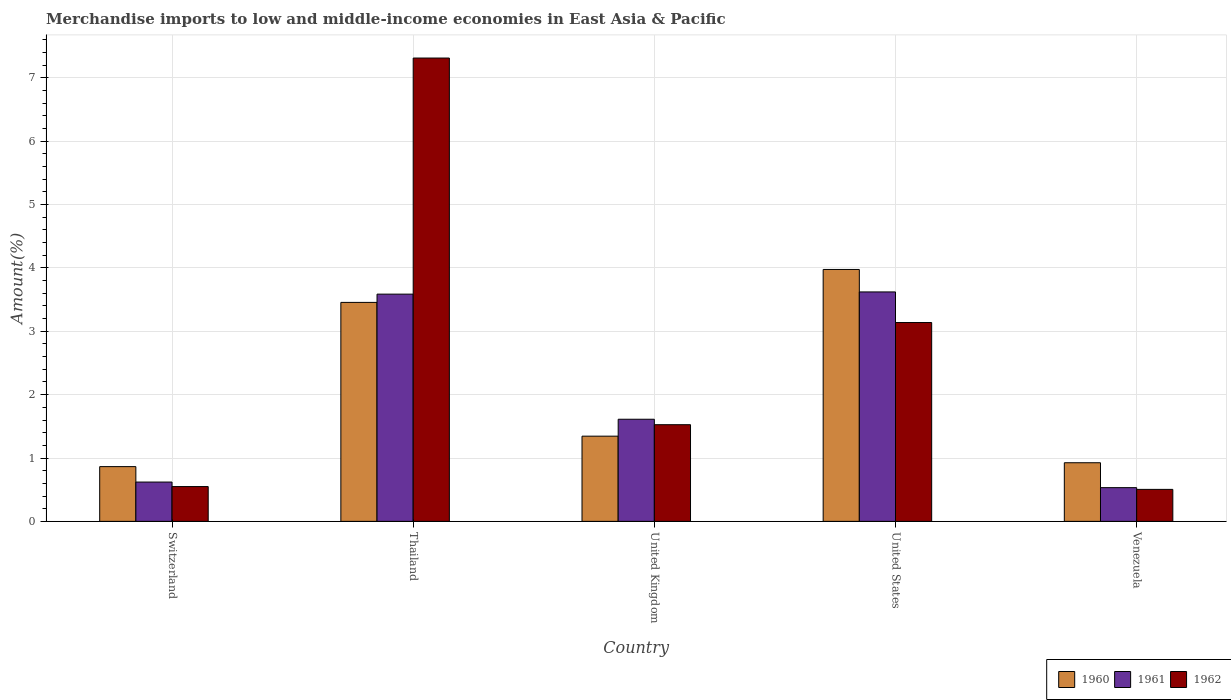How many groups of bars are there?
Make the answer very short. 5. Are the number of bars per tick equal to the number of legend labels?
Offer a very short reply. Yes. Are the number of bars on each tick of the X-axis equal?
Your answer should be very brief. Yes. How many bars are there on the 3rd tick from the right?
Provide a succinct answer. 3. What is the label of the 1st group of bars from the left?
Ensure brevity in your answer.  Switzerland. What is the percentage of amount earned from merchandise imports in 1962 in Thailand?
Provide a short and direct response. 7.31. Across all countries, what is the maximum percentage of amount earned from merchandise imports in 1961?
Give a very brief answer. 3.62. Across all countries, what is the minimum percentage of amount earned from merchandise imports in 1961?
Offer a terse response. 0.53. In which country was the percentage of amount earned from merchandise imports in 1960 minimum?
Provide a short and direct response. Switzerland. What is the total percentage of amount earned from merchandise imports in 1962 in the graph?
Keep it short and to the point. 13.03. What is the difference between the percentage of amount earned from merchandise imports in 1962 in United Kingdom and that in Venezuela?
Give a very brief answer. 1.02. What is the difference between the percentage of amount earned from merchandise imports in 1961 in United Kingdom and the percentage of amount earned from merchandise imports in 1962 in Venezuela?
Provide a succinct answer. 1.11. What is the average percentage of amount earned from merchandise imports in 1960 per country?
Give a very brief answer. 2.11. What is the difference between the percentage of amount earned from merchandise imports of/in 1962 and percentage of amount earned from merchandise imports of/in 1960 in Venezuela?
Ensure brevity in your answer.  -0.42. What is the ratio of the percentage of amount earned from merchandise imports in 1962 in United Kingdom to that in United States?
Ensure brevity in your answer.  0.49. Is the percentage of amount earned from merchandise imports in 1961 in Switzerland less than that in United Kingdom?
Keep it short and to the point. Yes. What is the difference between the highest and the second highest percentage of amount earned from merchandise imports in 1961?
Provide a succinct answer. 1.97. What is the difference between the highest and the lowest percentage of amount earned from merchandise imports in 1960?
Make the answer very short. 3.11. In how many countries, is the percentage of amount earned from merchandise imports in 1962 greater than the average percentage of amount earned from merchandise imports in 1962 taken over all countries?
Offer a very short reply. 2. Is it the case that in every country, the sum of the percentage of amount earned from merchandise imports in 1960 and percentage of amount earned from merchandise imports in 1961 is greater than the percentage of amount earned from merchandise imports in 1962?
Offer a terse response. No. How many bars are there?
Your answer should be compact. 15. How many countries are there in the graph?
Offer a very short reply. 5. Are the values on the major ticks of Y-axis written in scientific E-notation?
Offer a very short reply. No. Does the graph contain any zero values?
Offer a very short reply. No. How many legend labels are there?
Keep it short and to the point. 3. How are the legend labels stacked?
Offer a very short reply. Horizontal. What is the title of the graph?
Make the answer very short. Merchandise imports to low and middle-income economies in East Asia & Pacific. What is the label or title of the X-axis?
Your answer should be compact. Country. What is the label or title of the Y-axis?
Provide a short and direct response. Amount(%). What is the Amount(%) of 1960 in Switzerland?
Provide a short and direct response. 0.86. What is the Amount(%) of 1961 in Switzerland?
Give a very brief answer. 0.62. What is the Amount(%) in 1962 in Switzerland?
Make the answer very short. 0.55. What is the Amount(%) in 1960 in Thailand?
Keep it short and to the point. 3.46. What is the Amount(%) in 1961 in Thailand?
Your response must be concise. 3.59. What is the Amount(%) of 1962 in Thailand?
Offer a terse response. 7.31. What is the Amount(%) of 1960 in United Kingdom?
Keep it short and to the point. 1.34. What is the Amount(%) of 1961 in United Kingdom?
Provide a succinct answer. 1.61. What is the Amount(%) in 1962 in United Kingdom?
Keep it short and to the point. 1.53. What is the Amount(%) in 1960 in United States?
Keep it short and to the point. 3.98. What is the Amount(%) of 1961 in United States?
Your answer should be compact. 3.62. What is the Amount(%) of 1962 in United States?
Provide a succinct answer. 3.14. What is the Amount(%) in 1960 in Venezuela?
Your response must be concise. 0.93. What is the Amount(%) of 1961 in Venezuela?
Make the answer very short. 0.53. What is the Amount(%) of 1962 in Venezuela?
Your answer should be very brief. 0.5. Across all countries, what is the maximum Amount(%) of 1960?
Provide a succinct answer. 3.98. Across all countries, what is the maximum Amount(%) in 1961?
Offer a very short reply. 3.62. Across all countries, what is the maximum Amount(%) in 1962?
Offer a terse response. 7.31. Across all countries, what is the minimum Amount(%) in 1960?
Provide a succinct answer. 0.86. Across all countries, what is the minimum Amount(%) of 1961?
Make the answer very short. 0.53. Across all countries, what is the minimum Amount(%) in 1962?
Give a very brief answer. 0.5. What is the total Amount(%) of 1960 in the graph?
Provide a short and direct response. 10.57. What is the total Amount(%) of 1961 in the graph?
Give a very brief answer. 9.97. What is the total Amount(%) of 1962 in the graph?
Provide a succinct answer. 13.03. What is the difference between the Amount(%) of 1960 in Switzerland and that in Thailand?
Ensure brevity in your answer.  -2.59. What is the difference between the Amount(%) of 1961 in Switzerland and that in Thailand?
Your response must be concise. -2.97. What is the difference between the Amount(%) of 1962 in Switzerland and that in Thailand?
Your answer should be very brief. -6.76. What is the difference between the Amount(%) in 1960 in Switzerland and that in United Kingdom?
Provide a succinct answer. -0.48. What is the difference between the Amount(%) of 1961 in Switzerland and that in United Kingdom?
Give a very brief answer. -0.99. What is the difference between the Amount(%) of 1962 in Switzerland and that in United Kingdom?
Your answer should be very brief. -0.98. What is the difference between the Amount(%) in 1960 in Switzerland and that in United States?
Provide a succinct answer. -3.11. What is the difference between the Amount(%) in 1961 in Switzerland and that in United States?
Make the answer very short. -3. What is the difference between the Amount(%) of 1962 in Switzerland and that in United States?
Ensure brevity in your answer.  -2.59. What is the difference between the Amount(%) of 1960 in Switzerland and that in Venezuela?
Ensure brevity in your answer.  -0.06. What is the difference between the Amount(%) in 1961 in Switzerland and that in Venezuela?
Provide a succinct answer. 0.09. What is the difference between the Amount(%) of 1962 in Switzerland and that in Venezuela?
Your answer should be compact. 0.04. What is the difference between the Amount(%) in 1960 in Thailand and that in United Kingdom?
Offer a very short reply. 2.11. What is the difference between the Amount(%) in 1961 in Thailand and that in United Kingdom?
Offer a terse response. 1.97. What is the difference between the Amount(%) in 1962 in Thailand and that in United Kingdom?
Your response must be concise. 5.79. What is the difference between the Amount(%) of 1960 in Thailand and that in United States?
Your answer should be very brief. -0.52. What is the difference between the Amount(%) of 1961 in Thailand and that in United States?
Offer a very short reply. -0.04. What is the difference between the Amount(%) in 1962 in Thailand and that in United States?
Keep it short and to the point. 4.17. What is the difference between the Amount(%) of 1960 in Thailand and that in Venezuela?
Provide a succinct answer. 2.53. What is the difference between the Amount(%) in 1961 in Thailand and that in Venezuela?
Provide a short and direct response. 3.05. What is the difference between the Amount(%) of 1962 in Thailand and that in Venezuela?
Provide a succinct answer. 6.81. What is the difference between the Amount(%) of 1960 in United Kingdom and that in United States?
Your response must be concise. -2.63. What is the difference between the Amount(%) of 1961 in United Kingdom and that in United States?
Offer a terse response. -2.01. What is the difference between the Amount(%) in 1962 in United Kingdom and that in United States?
Offer a very short reply. -1.61. What is the difference between the Amount(%) in 1960 in United Kingdom and that in Venezuela?
Offer a terse response. 0.42. What is the difference between the Amount(%) in 1961 in United Kingdom and that in Venezuela?
Provide a short and direct response. 1.08. What is the difference between the Amount(%) in 1962 in United Kingdom and that in Venezuela?
Make the answer very short. 1.02. What is the difference between the Amount(%) in 1960 in United States and that in Venezuela?
Your response must be concise. 3.05. What is the difference between the Amount(%) in 1961 in United States and that in Venezuela?
Ensure brevity in your answer.  3.09. What is the difference between the Amount(%) of 1962 in United States and that in Venezuela?
Ensure brevity in your answer.  2.63. What is the difference between the Amount(%) of 1960 in Switzerland and the Amount(%) of 1961 in Thailand?
Your answer should be compact. -2.72. What is the difference between the Amount(%) in 1960 in Switzerland and the Amount(%) in 1962 in Thailand?
Provide a short and direct response. -6.45. What is the difference between the Amount(%) in 1961 in Switzerland and the Amount(%) in 1962 in Thailand?
Offer a very short reply. -6.69. What is the difference between the Amount(%) of 1960 in Switzerland and the Amount(%) of 1961 in United Kingdom?
Give a very brief answer. -0.75. What is the difference between the Amount(%) in 1960 in Switzerland and the Amount(%) in 1962 in United Kingdom?
Keep it short and to the point. -0.66. What is the difference between the Amount(%) of 1961 in Switzerland and the Amount(%) of 1962 in United Kingdom?
Your answer should be very brief. -0.91. What is the difference between the Amount(%) of 1960 in Switzerland and the Amount(%) of 1961 in United States?
Offer a very short reply. -2.76. What is the difference between the Amount(%) in 1960 in Switzerland and the Amount(%) in 1962 in United States?
Your answer should be compact. -2.27. What is the difference between the Amount(%) of 1961 in Switzerland and the Amount(%) of 1962 in United States?
Keep it short and to the point. -2.52. What is the difference between the Amount(%) in 1960 in Switzerland and the Amount(%) in 1961 in Venezuela?
Your response must be concise. 0.33. What is the difference between the Amount(%) in 1960 in Switzerland and the Amount(%) in 1962 in Venezuela?
Ensure brevity in your answer.  0.36. What is the difference between the Amount(%) in 1961 in Switzerland and the Amount(%) in 1962 in Venezuela?
Make the answer very short. 0.12. What is the difference between the Amount(%) of 1960 in Thailand and the Amount(%) of 1961 in United Kingdom?
Ensure brevity in your answer.  1.84. What is the difference between the Amount(%) of 1960 in Thailand and the Amount(%) of 1962 in United Kingdom?
Provide a short and direct response. 1.93. What is the difference between the Amount(%) in 1961 in Thailand and the Amount(%) in 1962 in United Kingdom?
Provide a short and direct response. 2.06. What is the difference between the Amount(%) in 1960 in Thailand and the Amount(%) in 1961 in United States?
Ensure brevity in your answer.  -0.17. What is the difference between the Amount(%) in 1960 in Thailand and the Amount(%) in 1962 in United States?
Offer a terse response. 0.32. What is the difference between the Amount(%) of 1961 in Thailand and the Amount(%) of 1962 in United States?
Offer a terse response. 0.45. What is the difference between the Amount(%) in 1960 in Thailand and the Amount(%) in 1961 in Venezuela?
Your response must be concise. 2.92. What is the difference between the Amount(%) of 1960 in Thailand and the Amount(%) of 1962 in Venezuela?
Give a very brief answer. 2.95. What is the difference between the Amount(%) in 1961 in Thailand and the Amount(%) in 1962 in Venezuela?
Your answer should be compact. 3.08. What is the difference between the Amount(%) in 1960 in United Kingdom and the Amount(%) in 1961 in United States?
Your answer should be very brief. -2.28. What is the difference between the Amount(%) of 1960 in United Kingdom and the Amount(%) of 1962 in United States?
Provide a short and direct response. -1.79. What is the difference between the Amount(%) in 1961 in United Kingdom and the Amount(%) in 1962 in United States?
Give a very brief answer. -1.53. What is the difference between the Amount(%) of 1960 in United Kingdom and the Amount(%) of 1961 in Venezuela?
Keep it short and to the point. 0.81. What is the difference between the Amount(%) of 1960 in United Kingdom and the Amount(%) of 1962 in Venezuela?
Your answer should be very brief. 0.84. What is the difference between the Amount(%) in 1961 in United Kingdom and the Amount(%) in 1962 in Venezuela?
Your response must be concise. 1.11. What is the difference between the Amount(%) of 1960 in United States and the Amount(%) of 1961 in Venezuela?
Make the answer very short. 3.44. What is the difference between the Amount(%) in 1960 in United States and the Amount(%) in 1962 in Venezuela?
Offer a terse response. 3.47. What is the difference between the Amount(%) of 1961 in United States and the Amount(%) of 1962 in Venezuela?
Your answer should be very brief. 3.12. What is the average Amount(%) of 1960 per country?
Make the answer very short. 2.11. What is the average Amount(%) of 1961 per country?
Offer a very short reply. 1.99. What is the average Amount(%) in 1962 per country?
Keep it short and to the point. 2.61. What is the difference between the Amount(%) in 1960 and Amount(%) in 1961 in Switzerland?
Offer a very short reply. 0.24. What is the difference between the Amount(%) in 1960 and Amount(%) in 1962 in Switzerland?
Keep it short and to the point. 0.31. What is the difference between the Amount(%) of 1961 and Amount(%) of 1962 in Switzerland?
Give a very brief answer. 0.07. What is the difference between the Amount(%) in 1960 and Amount(%) in 1961 in Thailand?
Keep it short and to the point. -0.13. What is the difference between the Amount(%) in 1960 and Amount(%) in 1962 in Thailand?
Your response must be concise. -3.86. What is the difference between the Amount(%) of 1961 and Amount(%) of 1962 in Thailand?
Make the answer very short. -3.73. What is the difference between the Amount(%) of 1960 and Amount(%) of 1961 in United Kingdom?
Your answer should be compact. -0.27. What is the difference between the Amount(%) in 1960 and Amount(%) in 1962 in United Kingdom?
Offer a terse response. -0.18. What is the difference between the Amount(%) of 1961 and Amount(%) of 1962 in United Kingdom?
Provide a short and direct response. 0.09. What is the difference between the Amount(%) of 1960 and Amount(%) of 1961 in United States?
Provide a short and direct response. 0.35. What is the difference between the Amount(%) in 1960 and Amount(%) in 1962 in United States?
Your answer should be compact. 0.84. What is the difference between the Amount(%) of 1961 and Amount(%) of 1962 in United States?
Your answer should be compact. 0.48. What is the difference between the Amount(%) in 1960 and Amount(%) in 1961 in Venezuela?
Your answer should be compact. 0.39. What is the difference between the Amount(%) in 1960 and Amount(%) in 1962 in Venezuela?
Your answer should be compact. 0.42. What is the difference between the Amount(%) of 1961 and Amount(%) of 1962 in Venezuela?
Ensure brevity in your answer.  0.03. What is the ratio of the Amount(%) in 1961 in Switzerland to that in Thailand?
Your answer should be compact. 0.17. What is the ratio of the Amount(%) of 1962 in Switzerland to that in Thailand?
Your answer should be very brief. 0.08. What is the ratio of the Amount(%) of 1960 in Switzerland to that in United Kingdom?
Your answer should be compact. 0.64. What is the ratio of the Amount(%) in 1961 in Switzerland to that in United Kingdom?
Offer a terse response. 0.39. What is the ratio of the Amount(%) of 1962 in Switzerland to that in United Kingdom?
Make the answer very short. 0.36. What is the ratio of the Amount(%) of 1960 in Switzerland to that in United States?
Your answer should be very brief. 0.22. What is the ratio of the Amount(%) in 1961 in Switzerland to that in United States?
Provide a short and direct response. 0.17. What is the ratio of the Amount(%) in 1962 in Switzerland to that in United States?
Ensure brevity in your answer.  0.17. What is the ratio of the Amount(%) of 1960 in Switzerland to that in Venezuela?
Give a very brief answer. 0.93. What is the ratio of the Amount(%) in 1961 in Switzerland to that in Venezuela?
Your response must be concise. 1.17. What is the ratio of the Amount(%) in 1962 in Switzerland to that in Venezuela?
Your response must be concise. 1.09. What is the ratio of the Amount(%) in 1960 in Thailand to that in United Kingdom?
Keep it short and to the point. 2.57. What is the ratio of the Amount(%) of 1961 in Thailand to that in United Kingdom?
Offer a terse response. 2.23. What is the ratio of the Amount(%) of 1962 in Thailand to that in United Kingdom?
Provide a succinct answer. 4.79. What is the ratio of the Amount(%) of 1960 in Thailand to that in United States?
Give a very brief answer. 0.87. What is the ratio of the Amount(%) in 1961 in Thailand to that in United States?
Keep it short and to the point. 0.99. What is the ratio of the Amount(%) of 1962 in Thailand to that in United States?
Keep it short and to the point. 2.33. What is the ratio of the Amount(%) of 1960 in Thailand to that in Venezuela?
Offer a terse response. 3.74. What is the ratio of the Amount(%) in 1961 in Thailand to that in Venezuela?
Give a very brief answer. 6.74. What is the ratio of the Amount(%) in 1962 in Thailand to that in Venezuela?
Give a very brief answer. 14.49. What is the ratio of the Amount(%) in 1960 in United Kingdom to that in United States?
Provide a short and direct response. 0.34. What is the ratio of the Amount(%) of 1961 in United Kingdom to that in United States?
Ensure brevity in your answer.  0.45. What is the ratio of the Amount(%) of 1962 in United Kingdom to that in United States?
Give a very brief answer. 0.49. What is the ratio of the Amount(%) in 1960 in United Kingdom to that in Venezuela?
Make the answer very short. 1.45. What is the ratio of the Amount(%) in 1961 in United Kingdom to that in Venezuela?
Make the answer very short. 3.03. What is the ratio of the Amount(%) in 1962 in United Kingdom to that in Venezuela?
Offer a very short reply. 3.02. What is the ratio of the Amount(%) in 1960 in United States to that in Venezuela?
Your answer should be very brief. 4.3. What is the ratio of the Amount(%) of 1961 in United States to that in Venezuela?
Make the answer very short. 6.8. What is the ratio of the Amount(%) of 1962 in United States to that in Venezuela?
Keep it short and to the point. 6.22. What is the difference between the highest and the second highest Amount(%) of 1960?
Offer a very short reply. 0.52. What is the difference between the highest and the second highest Amount(%) of 1961?
Offer a terse response. 0.04. What is the difference between the highest and the second highest Amount(%) of 1962?
Ensure brevity in your answer.  4.17. What is the difference between the highest and the lowest Amount(%) in 1960?
Your answer should be very brief. 3.11. What is the difference between the highest and the lowest Amount(%) of 1961?
Offer a terse response. 3.09. What is the difference between the highest and the lowest Amount(%) of 1962?
Ensure brevity in your answer.  6.81. 